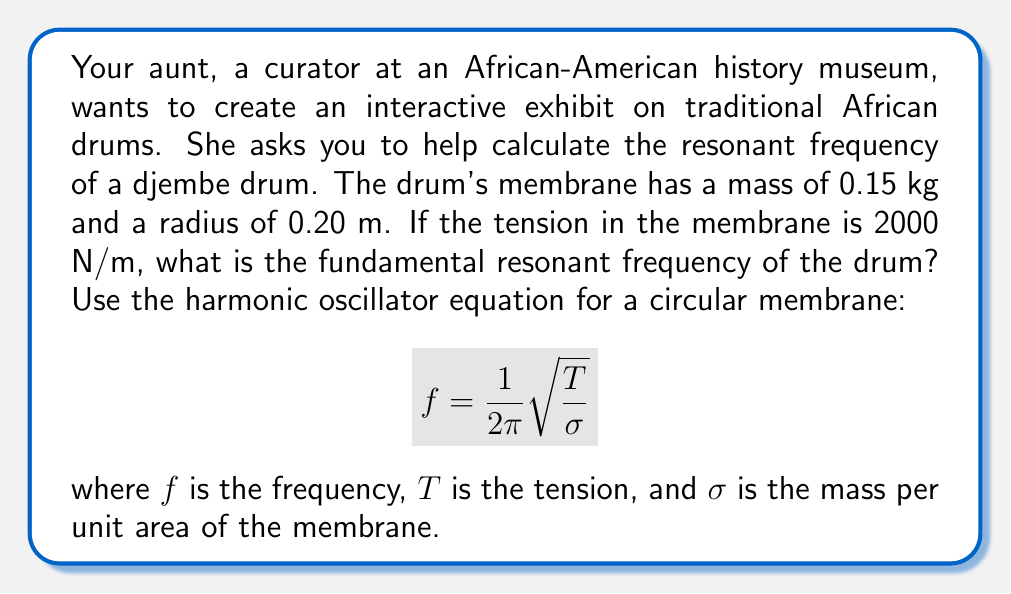Provide a solution to this math problem. To solve this problem, we need to follow these steps:

1. Calculate the area of the drum membrane:
   $$A = \pi r^2 = \pi (0.20 \text{ m})^2 = 0.1257 \text{ m}^2$$

2. Calculate the mass per unit area ($\sigma$):
   $$\sigma = \frac{m}{A} = \frac{0.15 \text{ kg}}{0.1257 \text{ m}^2} = 1.193 \text{ kg/m}^2$$

3. Use the given equation to calculate the resonant frequency:
   $$f = \frac{1}{2\pi}\sqrt{\frac{T}{\sigma}}$$
   
   Substituting the values:
   $$f = \frac{1}{2\pi}\sqrt{\frac{2000 \text{ N/m}}{1.193 \text{ kg/m}^2}}$$

4. Simplify and calculate:
   $$f = \frac{1}{2\pi}\sqrt{1676.45 \text{ m}^2/\text{s}^2}$$
   $$f = \frac{1}{2\pi}(40.94 \text{ m/s})$$
   $$f = 6.51 \text{ Hz}$$

Therefore, the fundamental resonant frequency of the djembe drum is approximately 6.51 Hz.
Answer: $f \approx 6.51 \text{ Hz}$ 